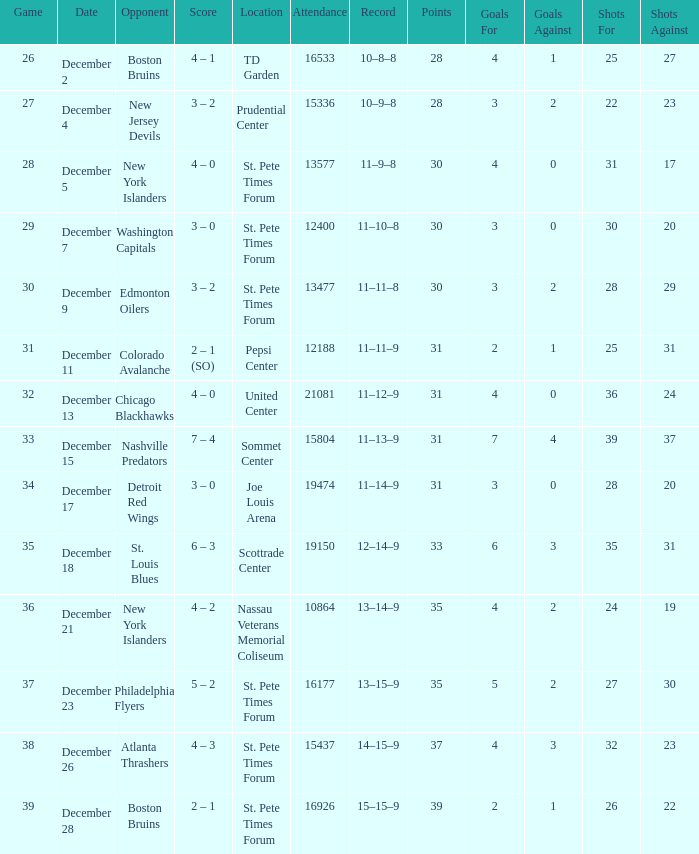What was the largest attended game? 21081.0. 